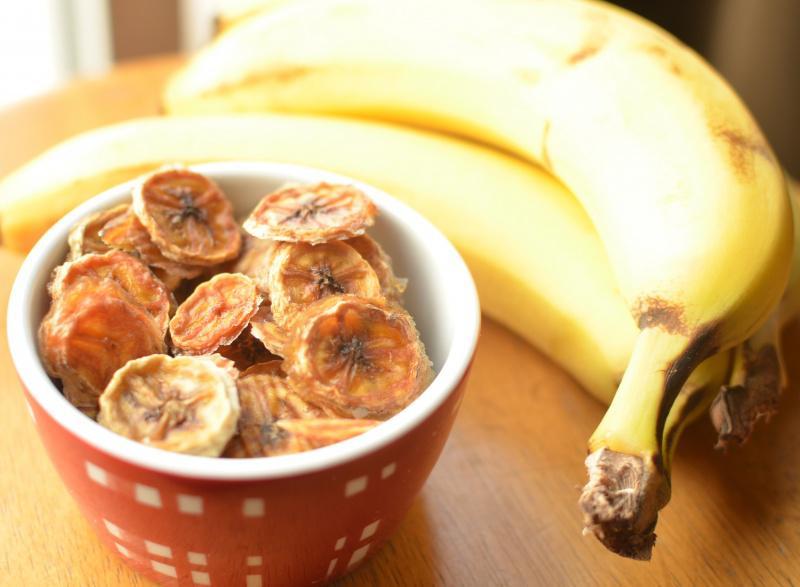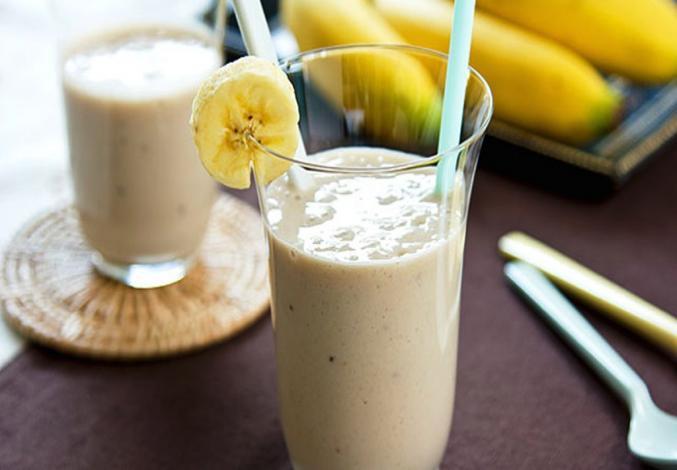The first image is the image on the left, the second image is the image on the right. For the images shown, is this caption "A glass containing a straw in a creamy beverage is in front of unpeeled bananas." true? Answer yes or no. Yes. 